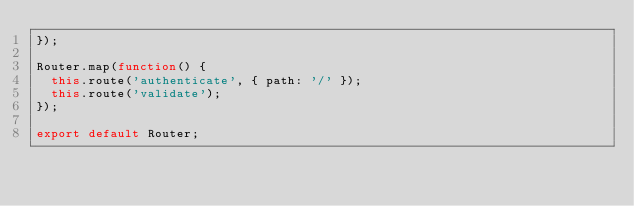<code> <loc_0><loc_0><loc_500><loc_500><_JavaScript_>});

Router.map(function() {
  this.route('authenticate', { path: '/' });
  this.route('validate');
});

export default Router;
</code> 